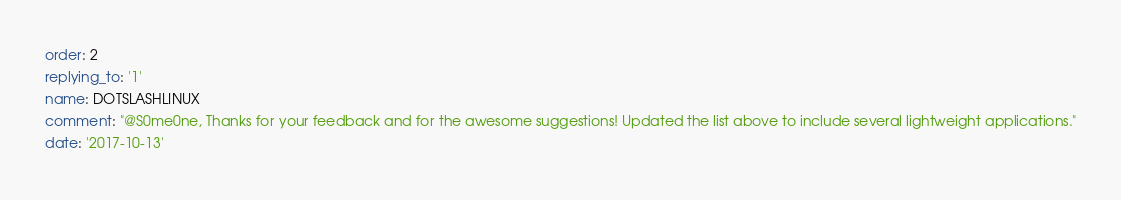<code> <loc_0><loc_0><loc_500><loc_500><_YAML_>order: 2
replying_to: '1'
name: DOTSLASHLINUX
comment: "@S0me0ne, Thanks for your feedback and for the awesome suggestions! Updated the list above to include several lightweight applications."
date: '2017-10-13'
</code> 